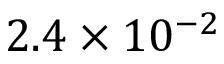Convert formula to latex. <formula><loc_0><loc_0><loc_500><loc_500>2 . 4 \times 1 0 ^ { - 2 }</formula> 